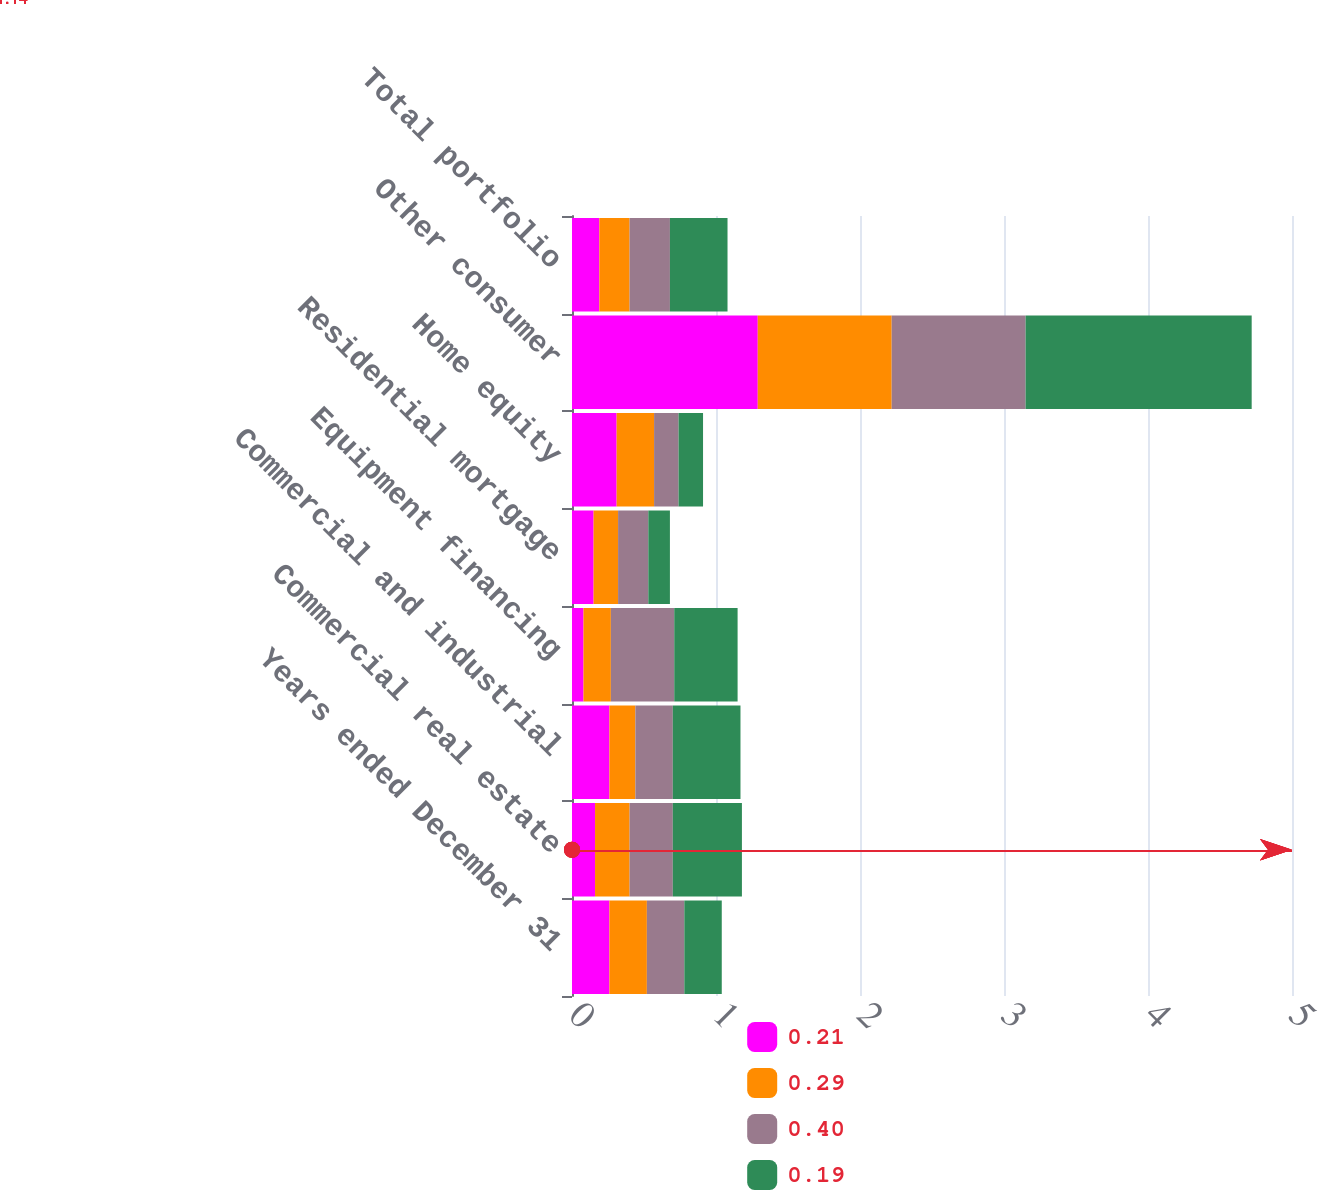Convert chart to OTSL. <chart><loc_0><loc_0><loc_500><loc_500><stacked_bar_chart><ecel><fcel>Years ended December 31<fcel>Commercial real estate<fcel>Commercial and industrial<fcel>Equipment financing<fcel>Residential mortgage<fcel>Home equity<fcel>Other consumer<fcel>Total portfolio<nl><fcel>0.21<fcel>0.26<fcel>0.16<fcel>0.26<fcel>0.08<fcel>0.15<fcel>0.31<fcel>1.29<fcel>0.19<nl><fcel>0.29<fcel>0.26<fcel>0.24<fcel>0.18<fcel>0.19<fcel>0.17<fcel>0.26<fcel>0.93<fcel>0.21<nl><fcel>0.4<fcel>0.26<fcel>0.3<fcel>0.26<fcel>0.44<fcel>0.21<fcel>0.17<fcel>0.93<fcel>0.28<nl><fcel>0.19<fcel>0.26<fcel>0.48<fcel>0.47<fcel>0.44<fcel>0.15<fcel>0.17<fcel>1.57<fcel>0.4<nl></chart> 